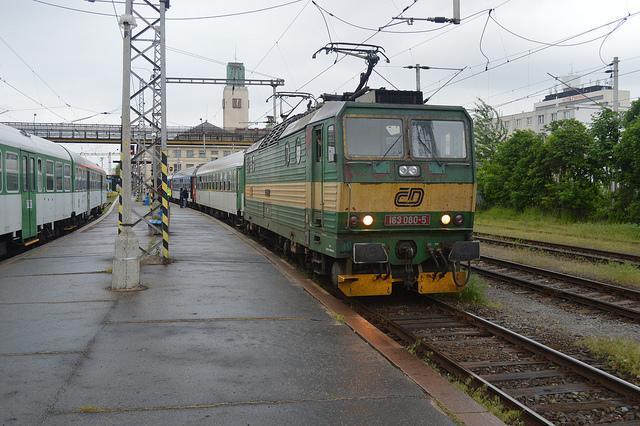How many trains can you see?
Give a very brief answer. 2. 